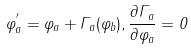<formula> <loc_0><loc_0><loc_500><loc_500>\varphi _ { a } ^ { ^ { \prime } } = \varphi _ { a } + \Gamma _ { a } ( \varphi _ { b } ) , \frac { \partial \Gamma _ { a } } { \partial \varphi _ { a } } = 0</formula> 